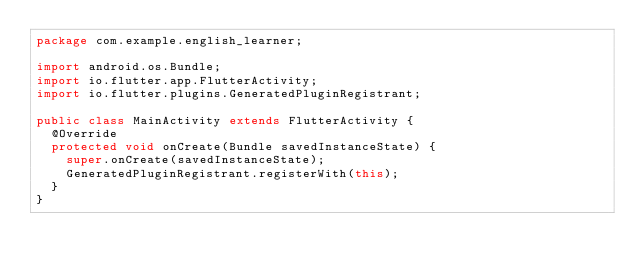Convert code to text. <code><loc_0><loc_0><loc_500><loc_500><_Java_>package com.example.english_learner;

import android.os.Bundle;
import io.flutter.app.FlutterActivity;
import io.flutter.plugins.GeneratedPluginRegistrant;

public class MainActivity extends FlutterActivity {
  @Override
  protected void onCreate(Bundle savedInstanceState) {
    super.onCreate(savedInstanceState);
    GeneratedPluginRegistrant.registerWith(this);
  }
}
</code> 